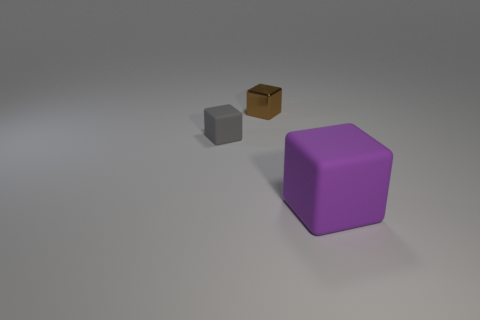Add 3 big brown spheres. How many objects exist? 6 Add 1 small blue cylinders. How many small blue cylinders exist? 1 Subtract 0 yellow cylinders. How many objects are left? 3 Subtract all small green objects. Subtract all small shiny blocks. How many objects are left? 2 Add 1 gray rubber objects. How many gray rubber objects are left? 2 